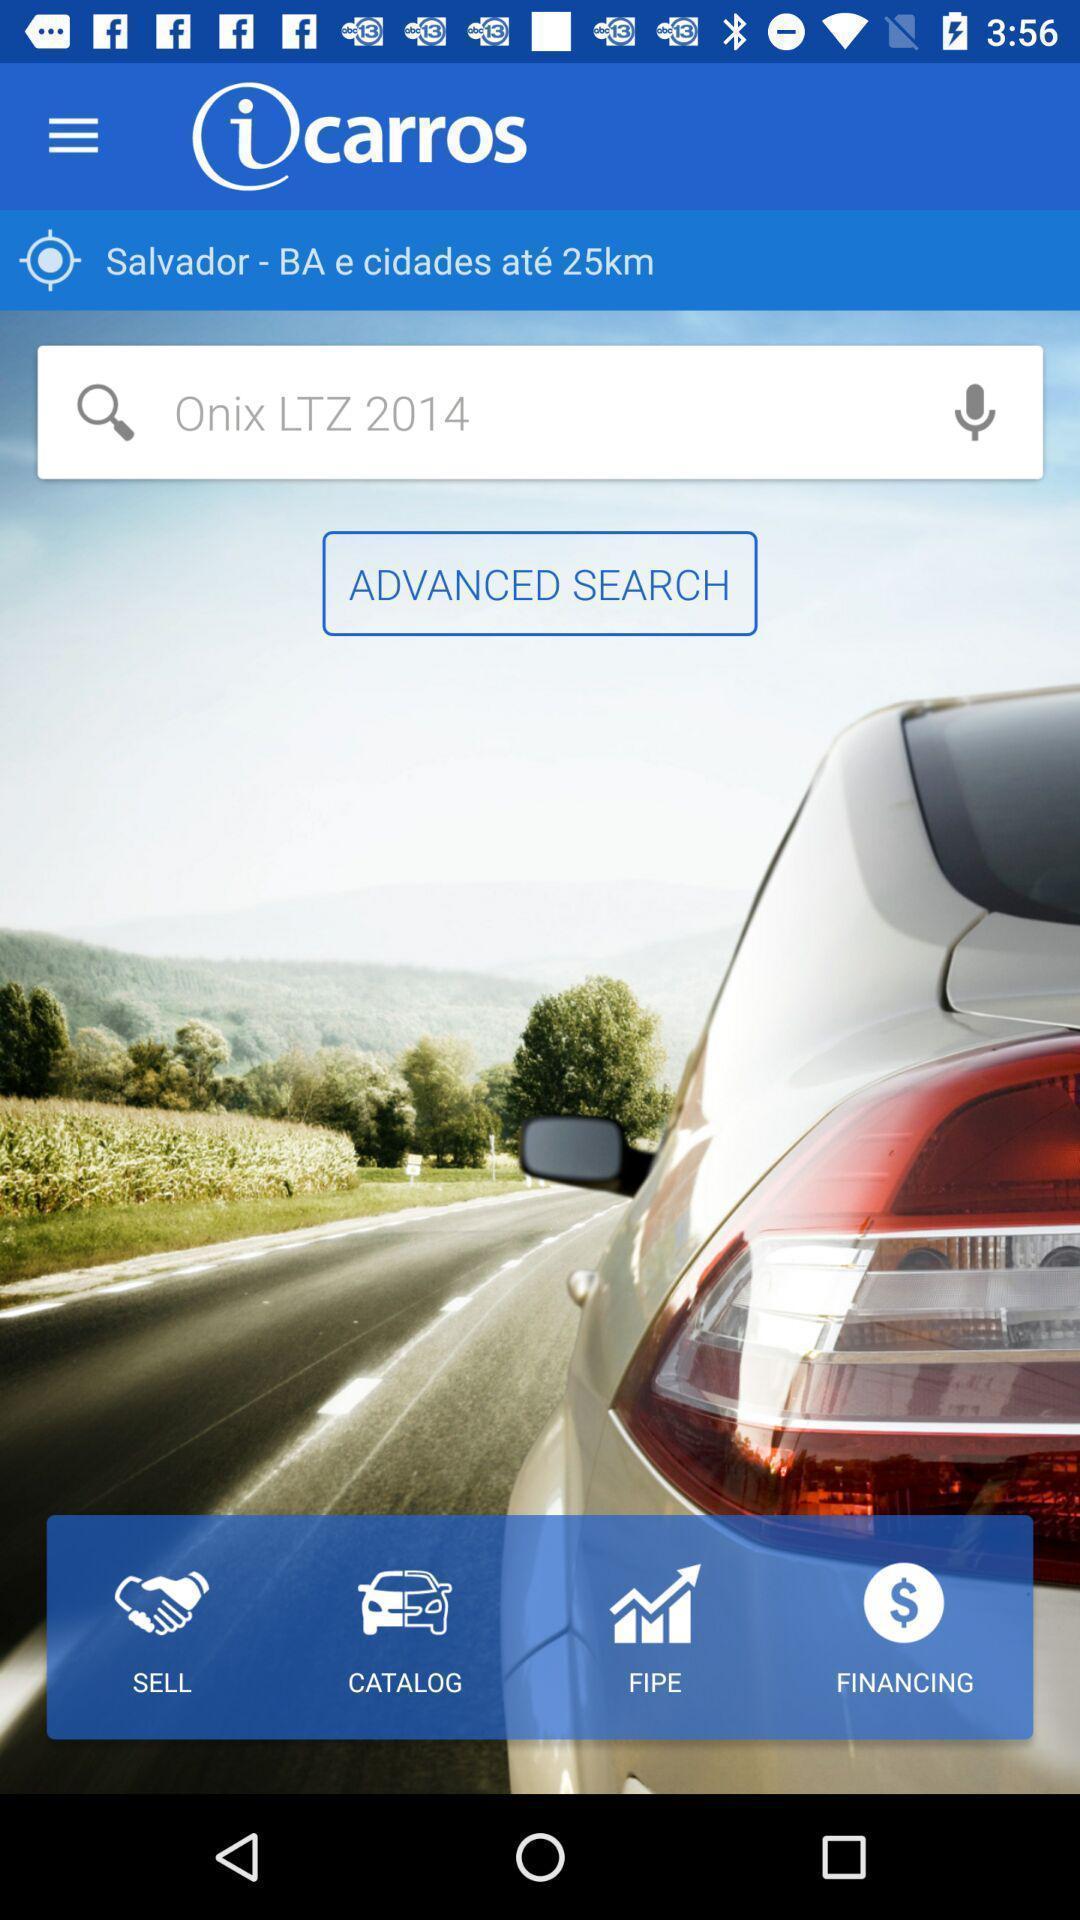Give me a narrative description of this picture. Welcome page. 